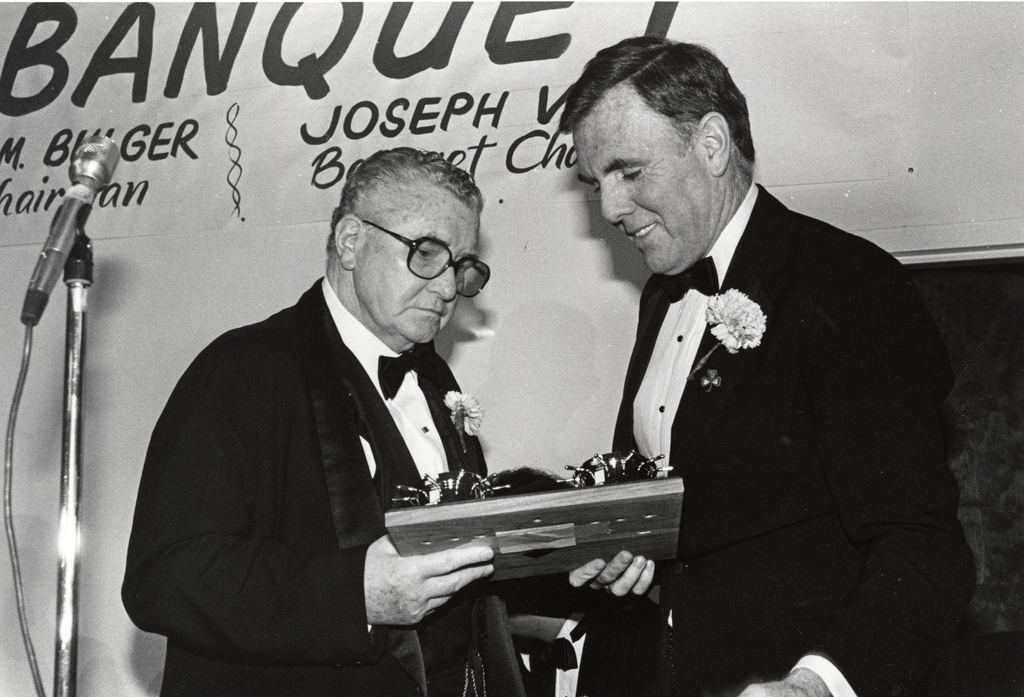How would you summarize this image in a sentence or two? This is a black and white image. There are a few people holding an object. We can see a microphone. In the background, we can see the wall with some text. We can also see an object on the right. 